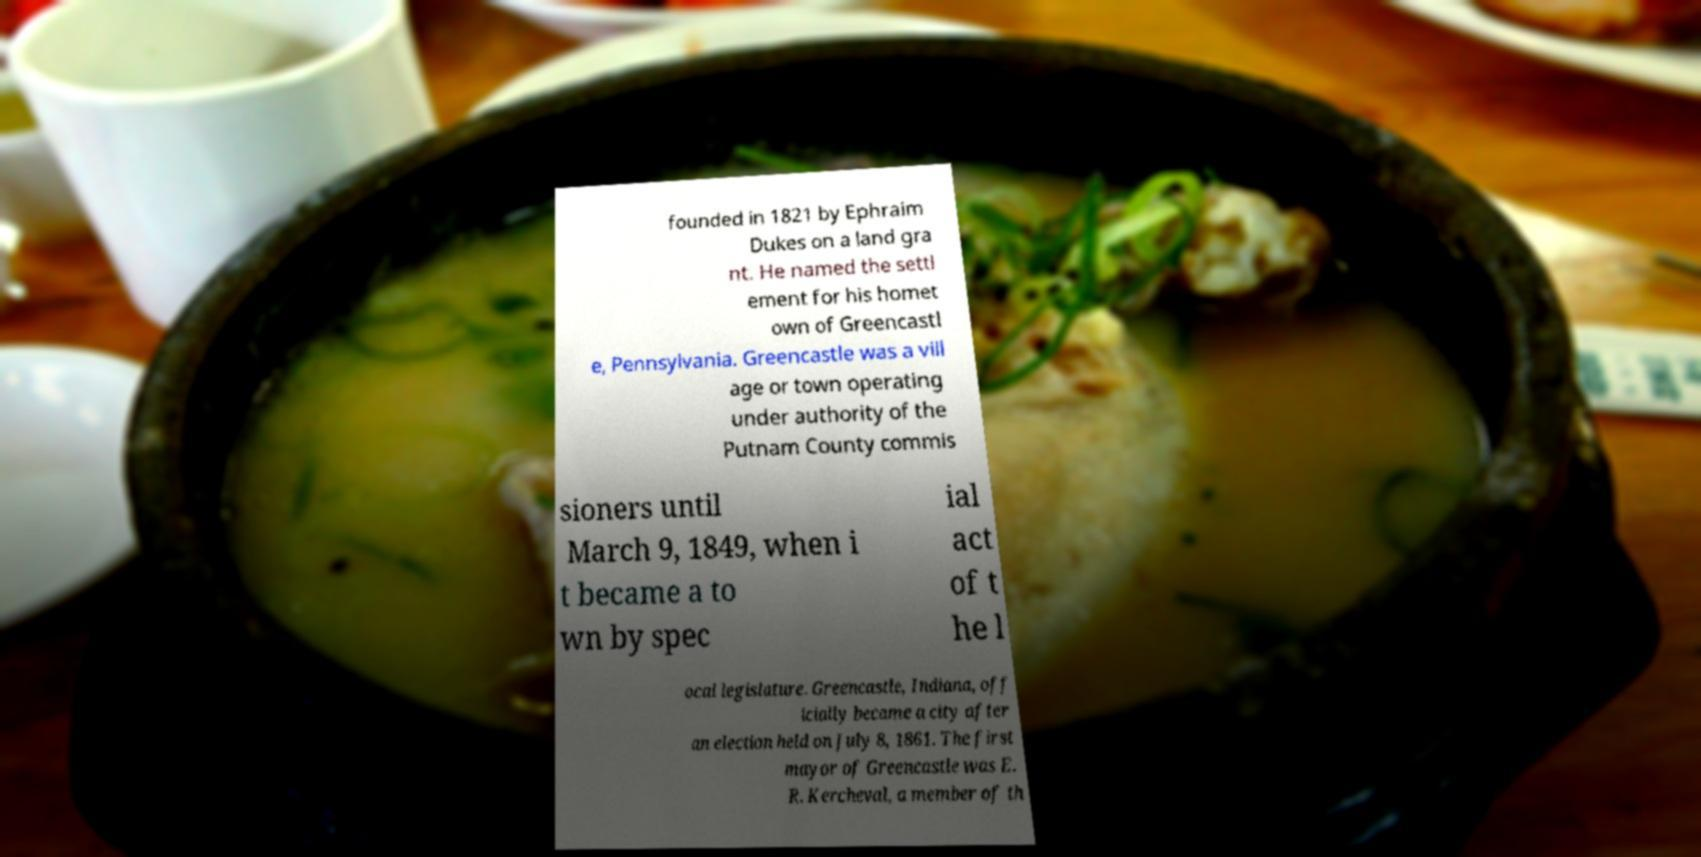Could you extract and type out the text from this image? founded in 1821 by Ephraim Dukes on a land gra nt. He named the settl ement for his homet own of Greencastl e, Pennsylvania. Greencastle was a vill age or town operating under authority of the Putnam County commis sioners until March 9, 1849, when i t became a to wn by spec ial act of t he l ocal legislature. Greencastle, Indiana, off icially became a city after an election held on July 8, 1861. The first mayor of Greencastle was E. R. Kercheval, a member of th 